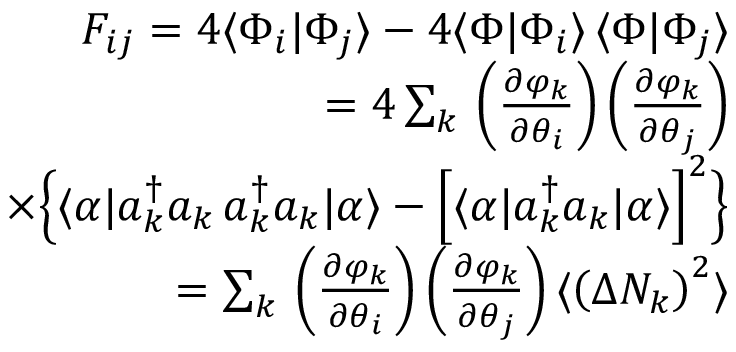<formula> <loc_0><loc_0><loc_500><loc_500>\begin{array} { r l r } & { F _ { i j } = 4 \langle \Phi _ { i } | \Phi _ { j } \rangle - 4 \langle \Phi | \Phi _ { i } \rangle \, \langle \Phi | \Phi _ { j } \rangle } \\ & { = 4 \sum _ { k } \, \left ( \frac { \partial \varphi _ { k } } { \partial \theta _ { i } } \right ) \left ( \frac { \partial \varphi _ { k } } { \partial \theta _ { j } } \right ) } \\ & { \times \left \{ \langle \alpha | a _ { k } ^ { \dagger } a _ { k } \, a _ { k } ^ { \dagger } a _ { k } | \alpha \rangle - \left [ \langle \alpha | a _ { k } ^ { \dagger } a _ { k } | \alpha \rangle \right ] ^ { 2 } \right \} } \\ & { = \sum _ { k } \, \left ( \frac { \partial \varphi _ { k } } { \partial \theta _ { i } } \right ) \left ( \frac { \partial \varphi _ { k } } { \partial \theta _ { j } } \right ) \langle \left ( \Delta N _ { k } \right ) ^ { 2 } \rangle } \end{array}</formula> 